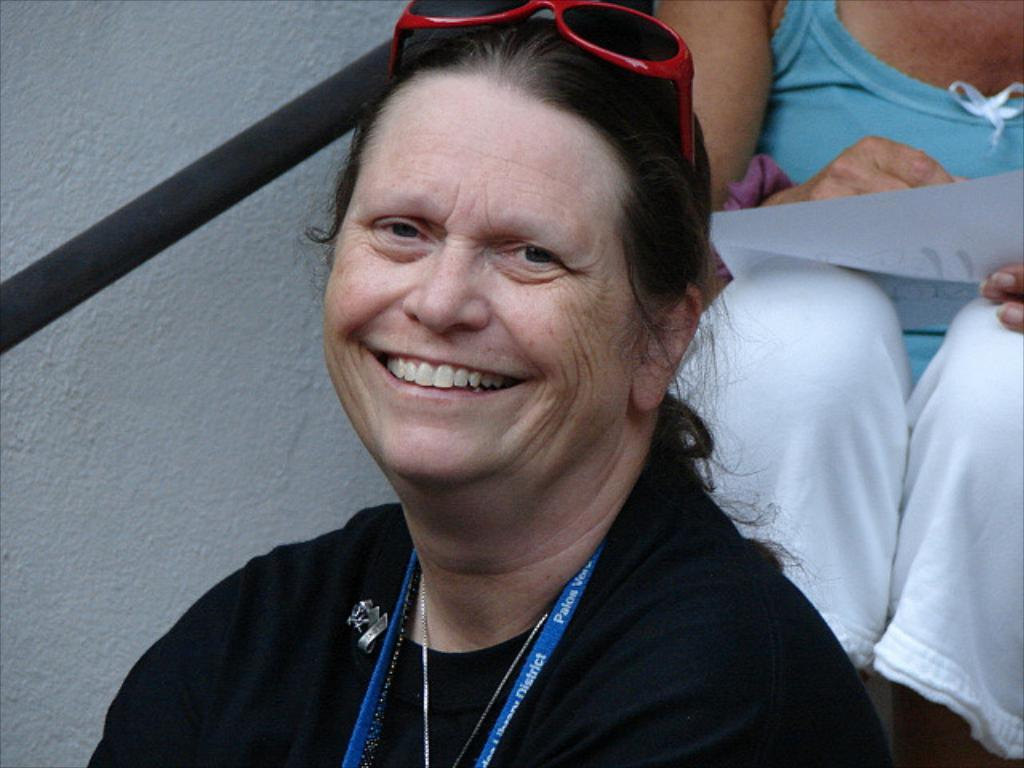What is the first person in the image wearing on their head? The first person in the image is wearing spectacles on their head. How many people are in the image? There are two people in the image. What is the second person holding? The second person is holding a paper. What type of volleyball is being played in the image? There is no volleyball present in the image. Can you see any smoke coming from the paper held by the second person? There is no smoke visible in the image. 